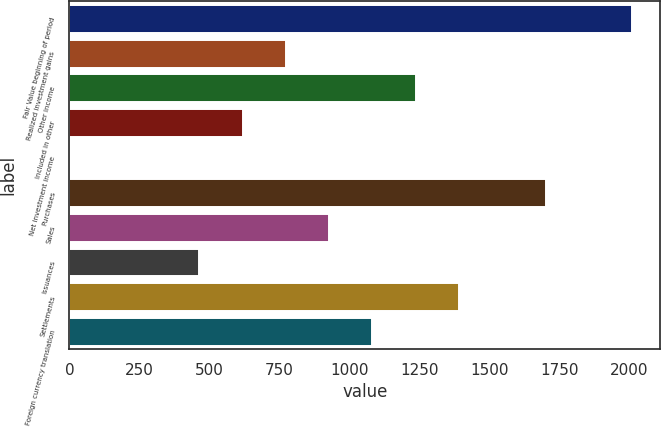Convert chart. <chart><loc_0><loc_0><loc_500><loc_500><bar_chart><fcel>Fair Value beginning of period<fcel>Realized investment gains<fcel>Other income<fcel>Included in other<fcel>Net investment income<fcel>Purchases<fcel>Sales<fcel>Issuances<fcel>Settlements<fcel>Foreign currency translation<nl><fcel>2010.91<fcel>773.71<fcel>1237.66<fcel>619.06<fcel>0.46<fcel>1701.61<fcel>928.36<fcel>464.41<fcel>1392.31<fcel>1083.01<nl></chart> 